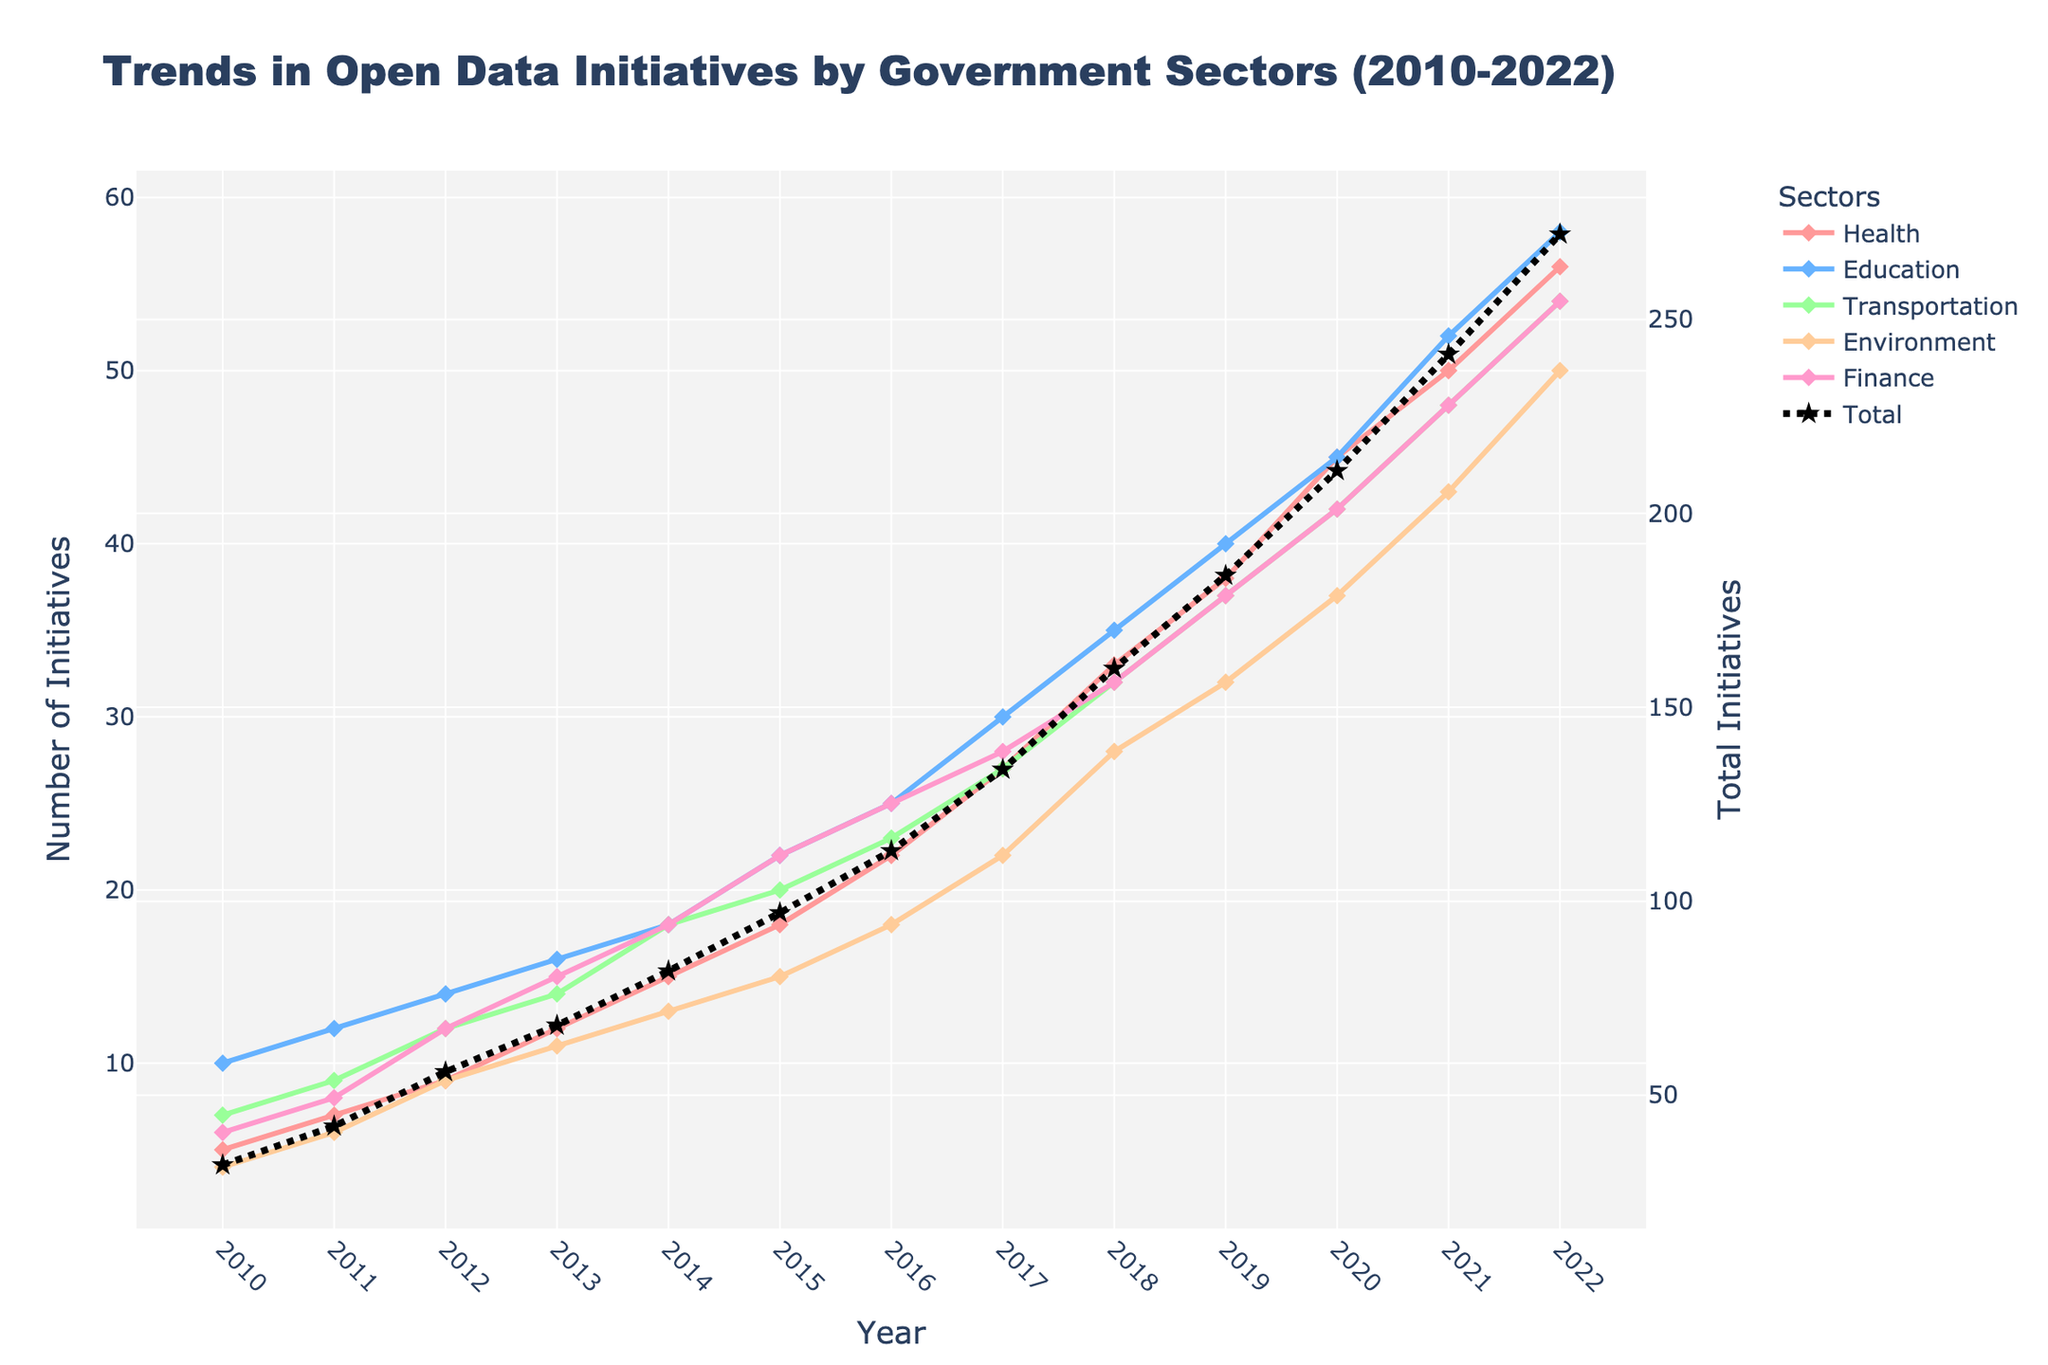what is the title of the plot? The title is located at the top of the figure, providing the main topic or subject of the data being visualized. In this case, the title gives an overview of the trends in open data initiatives by various government sectors.
Answer: Trends in Open Data Initiatives by Government Sectors (2010-2022) Which sector has the highest number of initiatives in 2022? To find this, look at the y-axis values for each sector in the year 2022 and identify the highest point.
Answer: Education What is the trend for the Transportation sector over the past decade? Observe the line representing the Transportation sector from 2010 to 2022. Note if the line is generally going upward, downward, or remains flat.
Answer: Upward trend How many total initiatives were there in 2015? Look at the Total trend line for the year 2015 and note its corresponding value on the secondary y-axis.
Answer: 93 Between which years did the Environment sector see the fastest growth? Identify the steepest incline in the Environment sector line plot. Steeper inclines indicate faster growth.
Answer: 2021 to 2022 How much did the number of Finance initiatives increase between 2010 and 2022? Compare the y-axis value for the Finance sector in 2010 (6) with the value in 2022 (54). Calculate the difference.
Answer: 48 What is the general pattern in the data for the Health and Environment sectors between 2010 and 2022? Compare trends for Health and Environment. Observe their shapes and overall growth patterns. Both sectors show a general increase.
Answer: Upward trend for both Which sectors have similar growth patterns? Look at the lines of different sectors and assess which ones have similar slopes and y-axis growth over time.
Answer: Health and Education During which year did the Education sector have the same number of initiatives as the Finance sector? Compare the points in the Education and Finance lines and find a year where their values match.
Answer: 2020 What is the average annual increase in initiatives for the Health sector from 2010 to 2022? Subtract the 2010 value from the 2022 value and divide by the number of years (2022-2010). Calculation: (56-5) / 12 = 4.25
Answer: 4.25 